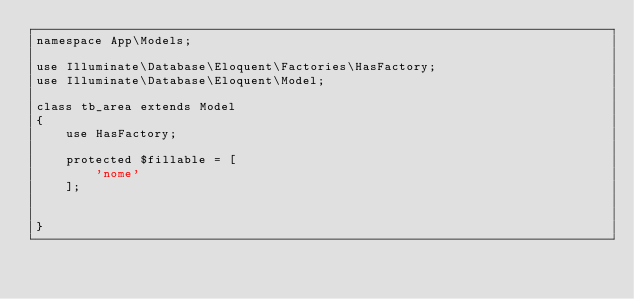Convert code to text. <code><loc_0><loc_0><loc_500><loc_500><_PHP_>namespace App\Models;

use Illuminate\Database\Eloquent\Factories\HasFactory;
use Illuminate\Database\Eloquent\Model;

class tb_area extends Model
{
    use HasFactory;

    protected $fillable = [
        'nome'
    ];


}
</code> 